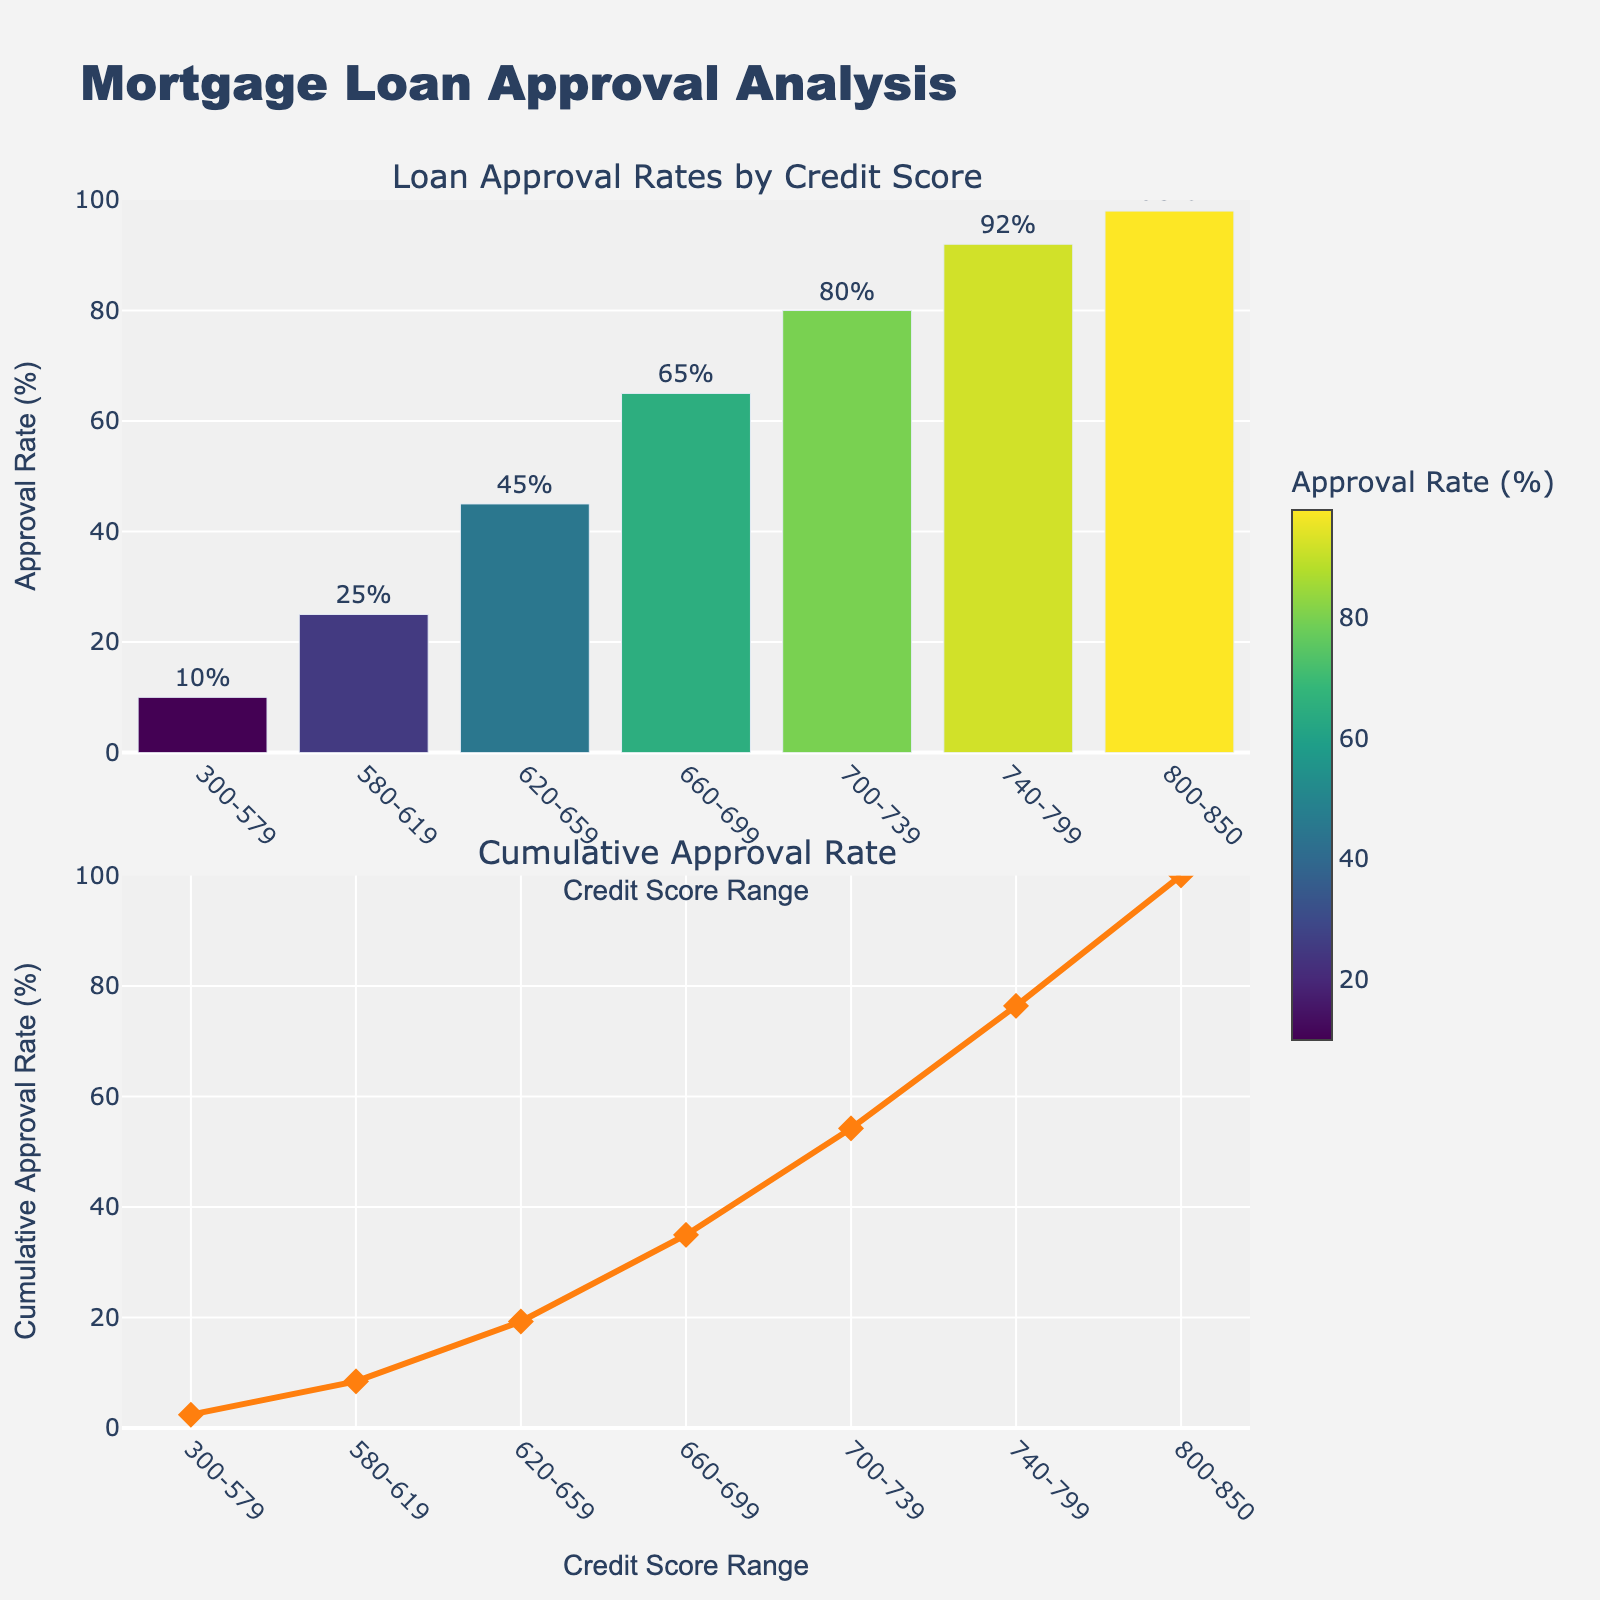What is the title of the whole figure? The title is given at the top of the plot. It says "Mortgage Loan Approval Analysis"
Answer: Mortgage Loan Approval Analysis What does the color scale represent in the first subplot? The color scale represents the "Approval Rate (%)" for each credit score range, where different colors indicate different approval rates.
Answer: Approval Rate (%) What is the approval rate for the 660-699 credit score range? Looking at the bar for the 660-699 range, the label on the bar shows the approval rate is 65%.
Answer: 65% How many credit score ranges are displayed in the first subplot? By counting the number of bars in the first subplot, there are 7 credit score ranges displayed.
Answer: 7 Which credit score range has the highest approval rate? The credit score range with the highest approval rate can be identified by finding the tallest bar. The 800-850 range has the highest approval rate of 98%.
Answer: 800-850 What trend can you observe in the cumulative approval rate as the credit score ranges increase? The cumulative approval rate line generally increases as the credit score ranges increase, indicating a larger proportion of approvals as credit scores get higher.
Answer: Increases What is the cumulative approval rate for the 740-799 credit score range? The diamond marker at the 740-799 credit score range in the second subplot shows the cumulative approval rate. The text above it indicates it is 92%.
Answer: 92% How does the approval rate change when moving from the 620-659 range to the 660-699 range? The approval rate for the 620-659 range is 45% and for the 660-699 range it is 65%. The difference is 65% - 45% = 20%.
Answer: Increases by 20% Which credit score range shows an approval rate that is closest to 50%? By examining the approval rates in the first subplot, the 620-659 range has an approval rate of 45%, which is closest to 50%.
Answer: 620-659 What is the color of the bar indicating the highest approval rate? The highest approval rate bar, which corresponds to the 800-850 range with a 98% approval rate, is the darkest color on the Viridis scale shown in the plot.
Answer: Darkest color on Viridis scale 